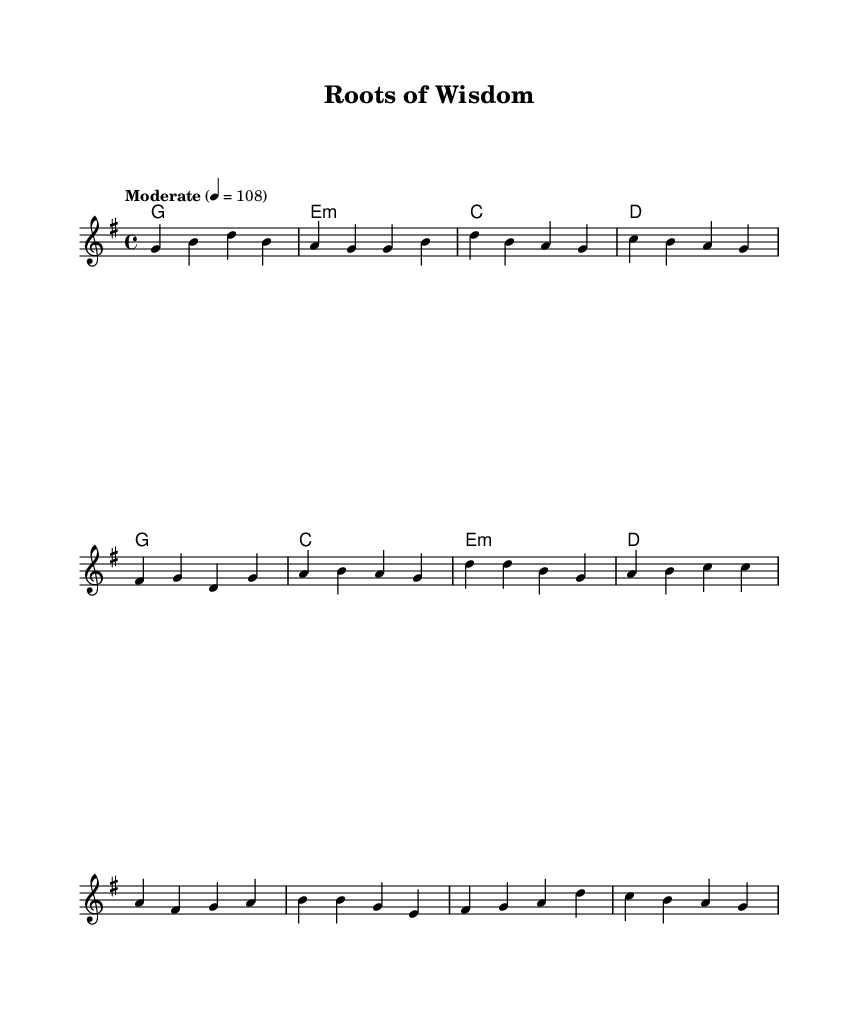What is the key signature of this music? The key signature is G major, which has one sharp (F#).
Answer: G major What is the time signature of the piece? The time signature is 4/4, indicating four beats in a measure.
Answer: 4/4 What is the tempo marking in the score? The tempo marking provided is "Moderate" at a metronome setting of 108 beats per minute.
Answer: Moderate 4 = 108 How many measures are there in the verse? The verse consists of 8 measures, as counted from the beginning to the end of the verse section.
Answer: 8 What is the last chord in the chorus? The last chord in the chorus is D major, as indicated in the harmonies for that section.
Answer: D What do the lyrics in the chorus suggest about the theme of the song? The lyrics imply a theme of enduring wisdom and legacy, highlighting the importance of lessons learned over time.
Answer: Enduring wisdom and legacy What type of chords are predominantly used in the verse? The verse predominantly uses major and minor chords, typical of Country Rock, creating a laid-back yet poignant sound.
Answer: Major and minor chords 